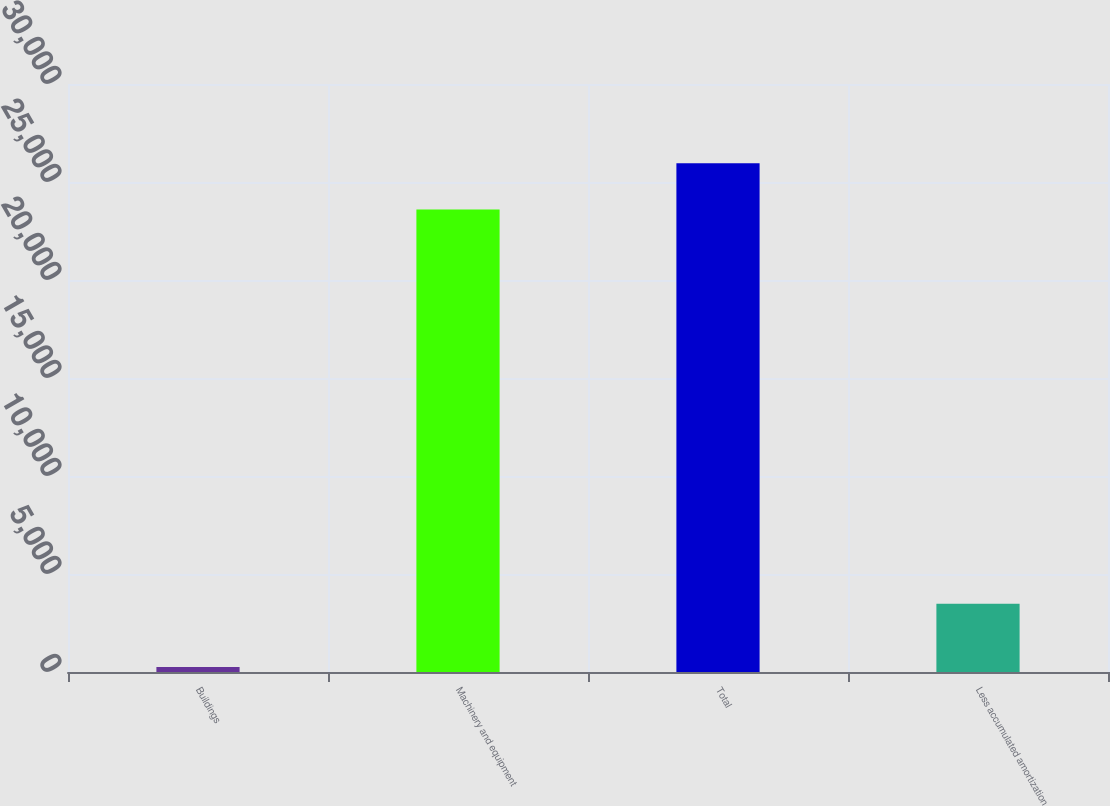Convert chart to OTSL. <chart><loc_0><loc_0><loc_500><loc_500><bar_chart><fcel>Buildings<fcel>Machinery and equipment<fcel>Total<fcel>Less accumulated amortization<nl><fcel>250<fcel>23602<fcel>25962.2<fcel>3481<nl></chart> 